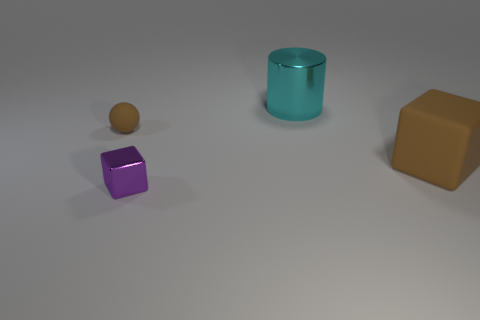Add 4 tiny spheres. How many objects exist? 8 Subtract all cylinders. How many objects are left? 3 Add 1 brown rubber cubes. How many brown rubber cubes are left? 2 Add 3 large cyan shiny cylinders. How many large cyan shiny cylinders exist? 4 Subtract 1 purple blocks. How many objects are left? 3 Subtract all green things. Subtract all large shiny cylinders. How many objects are left? 3 